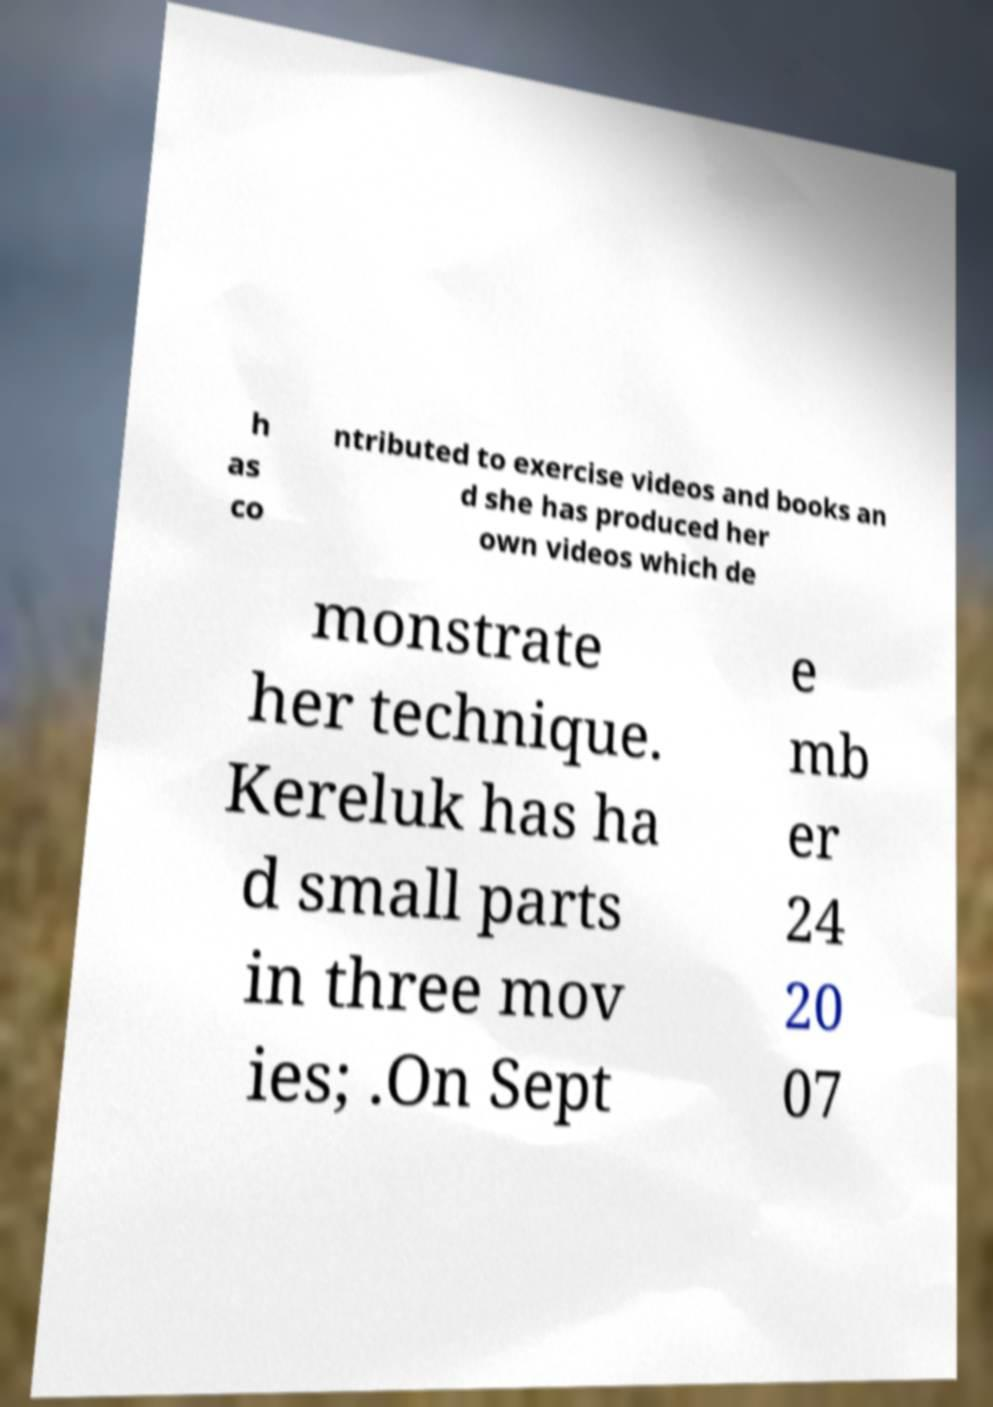What messages or text are displayed in this image? I need them in a readable, typed format. h as co ntributed to exercise videos and books an d she has produced her own videos which de monstrate her technique. Kereluk has ha d small parts in three mov ies; .On Sept e mb er 24 20 07 